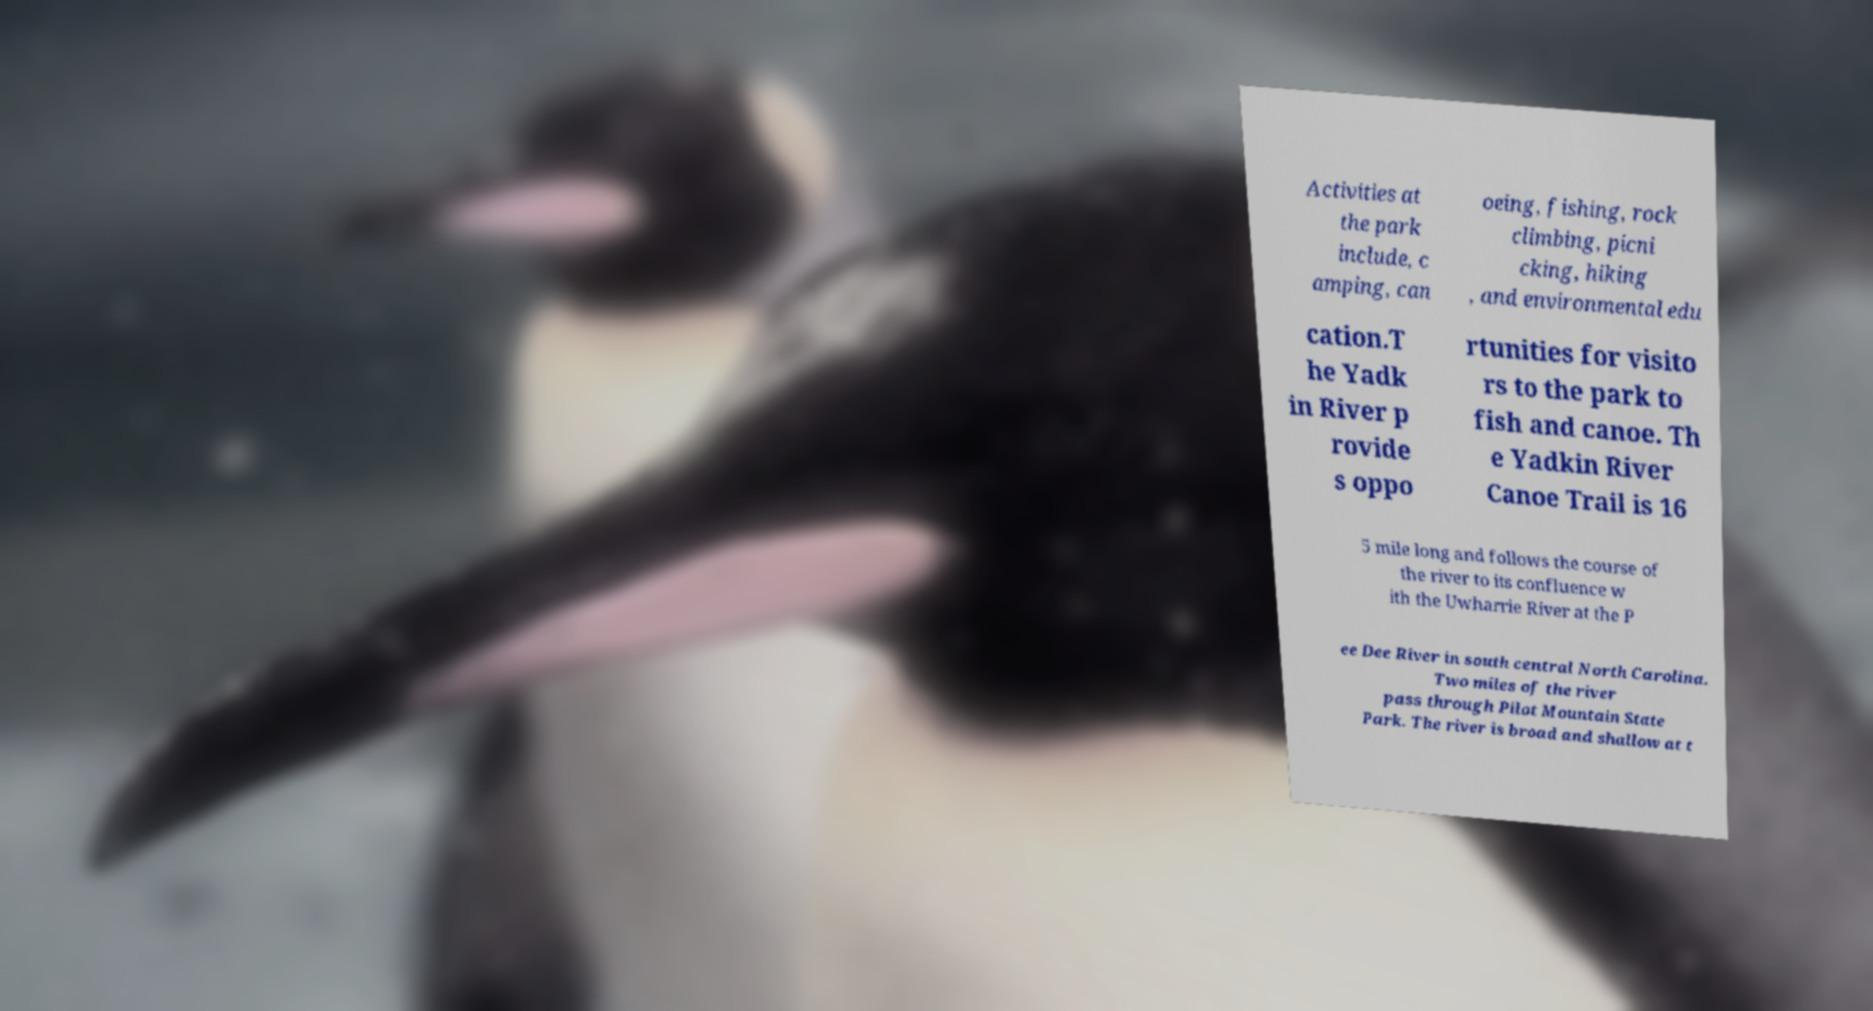I need the written content from this picture converted into text. Can you do that? Activities at the park include, c amping, can oeing, fishing, rock climbing, picni cking, hiking , and environmental edu cation.T he Yadk in River p rovide s oppo rtunities for visito rs to the park to fish and canoe. Th e Yadkin River Canoe Trail is 16 5 mile long and follows the course of the river to its confluence w ith the Uwharrie River at the P ee Dee River in south central North Carolina. Two miles of the river pass through Pilot Mountain State Park. The river is broad and shallow at t 